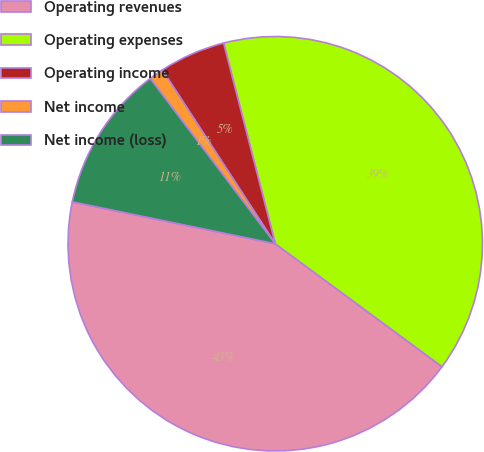<chart> <loc_0><loc_0><loc_500><loc_500><pie_chart><fcel>Operating revenues<fcel>Operating expenses<fcel>Operating income<fcel>Net income<fcel>Net income (loss)<nl><fcel>43.13%<fcel>39.12%<fcel>5.16%<fcel>1.14%<fcel>11.45%<nl></chart> 